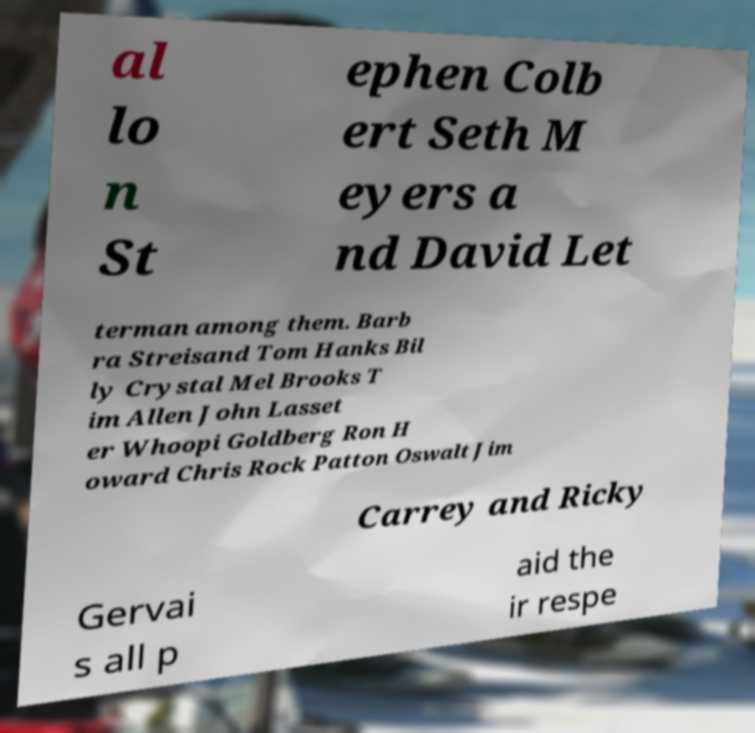What messages or text are displayed in this image? I need them in a readable, typed format. al lo n St ephen Colb ert Seth M eyers a nd David Let terman among them. Barb ra Streisand Tom Hanks Bil ly Crystal Mel Brooks T im Allen John Lasset er Whoopi Goldberg Ron H oward Chris Rock Patton Oswalt Jim Carrey and Ricky Gervai s all p aid the ir respe 